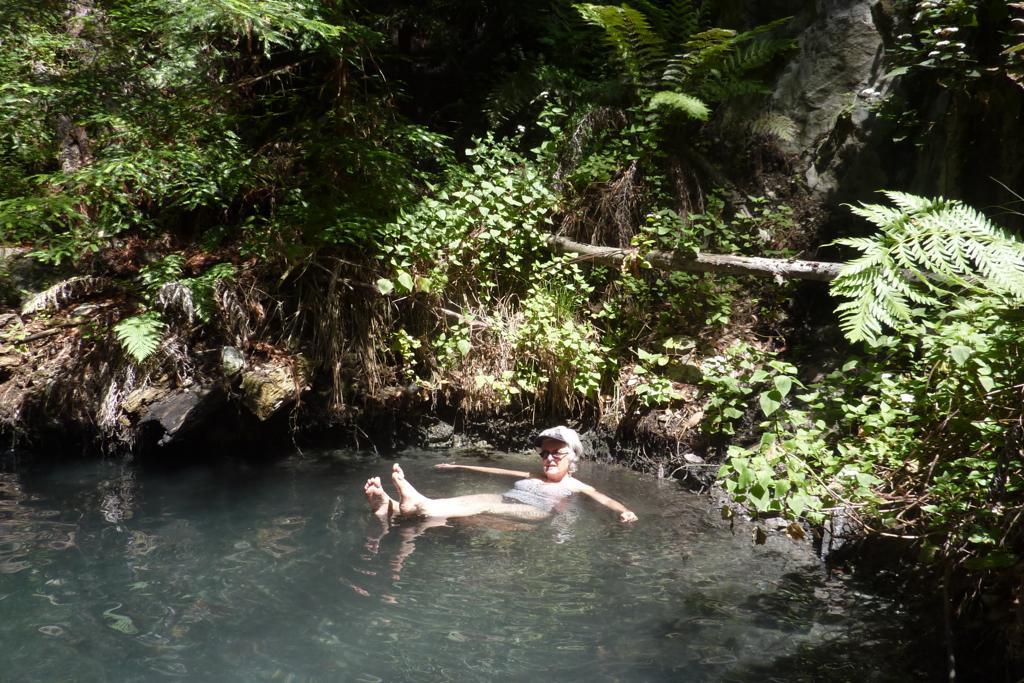How would you summarize this image in a sentence or two? In this image I can see the water, a person in the water and few trees which are green and brown in color. In the background I can see a huge rock. 